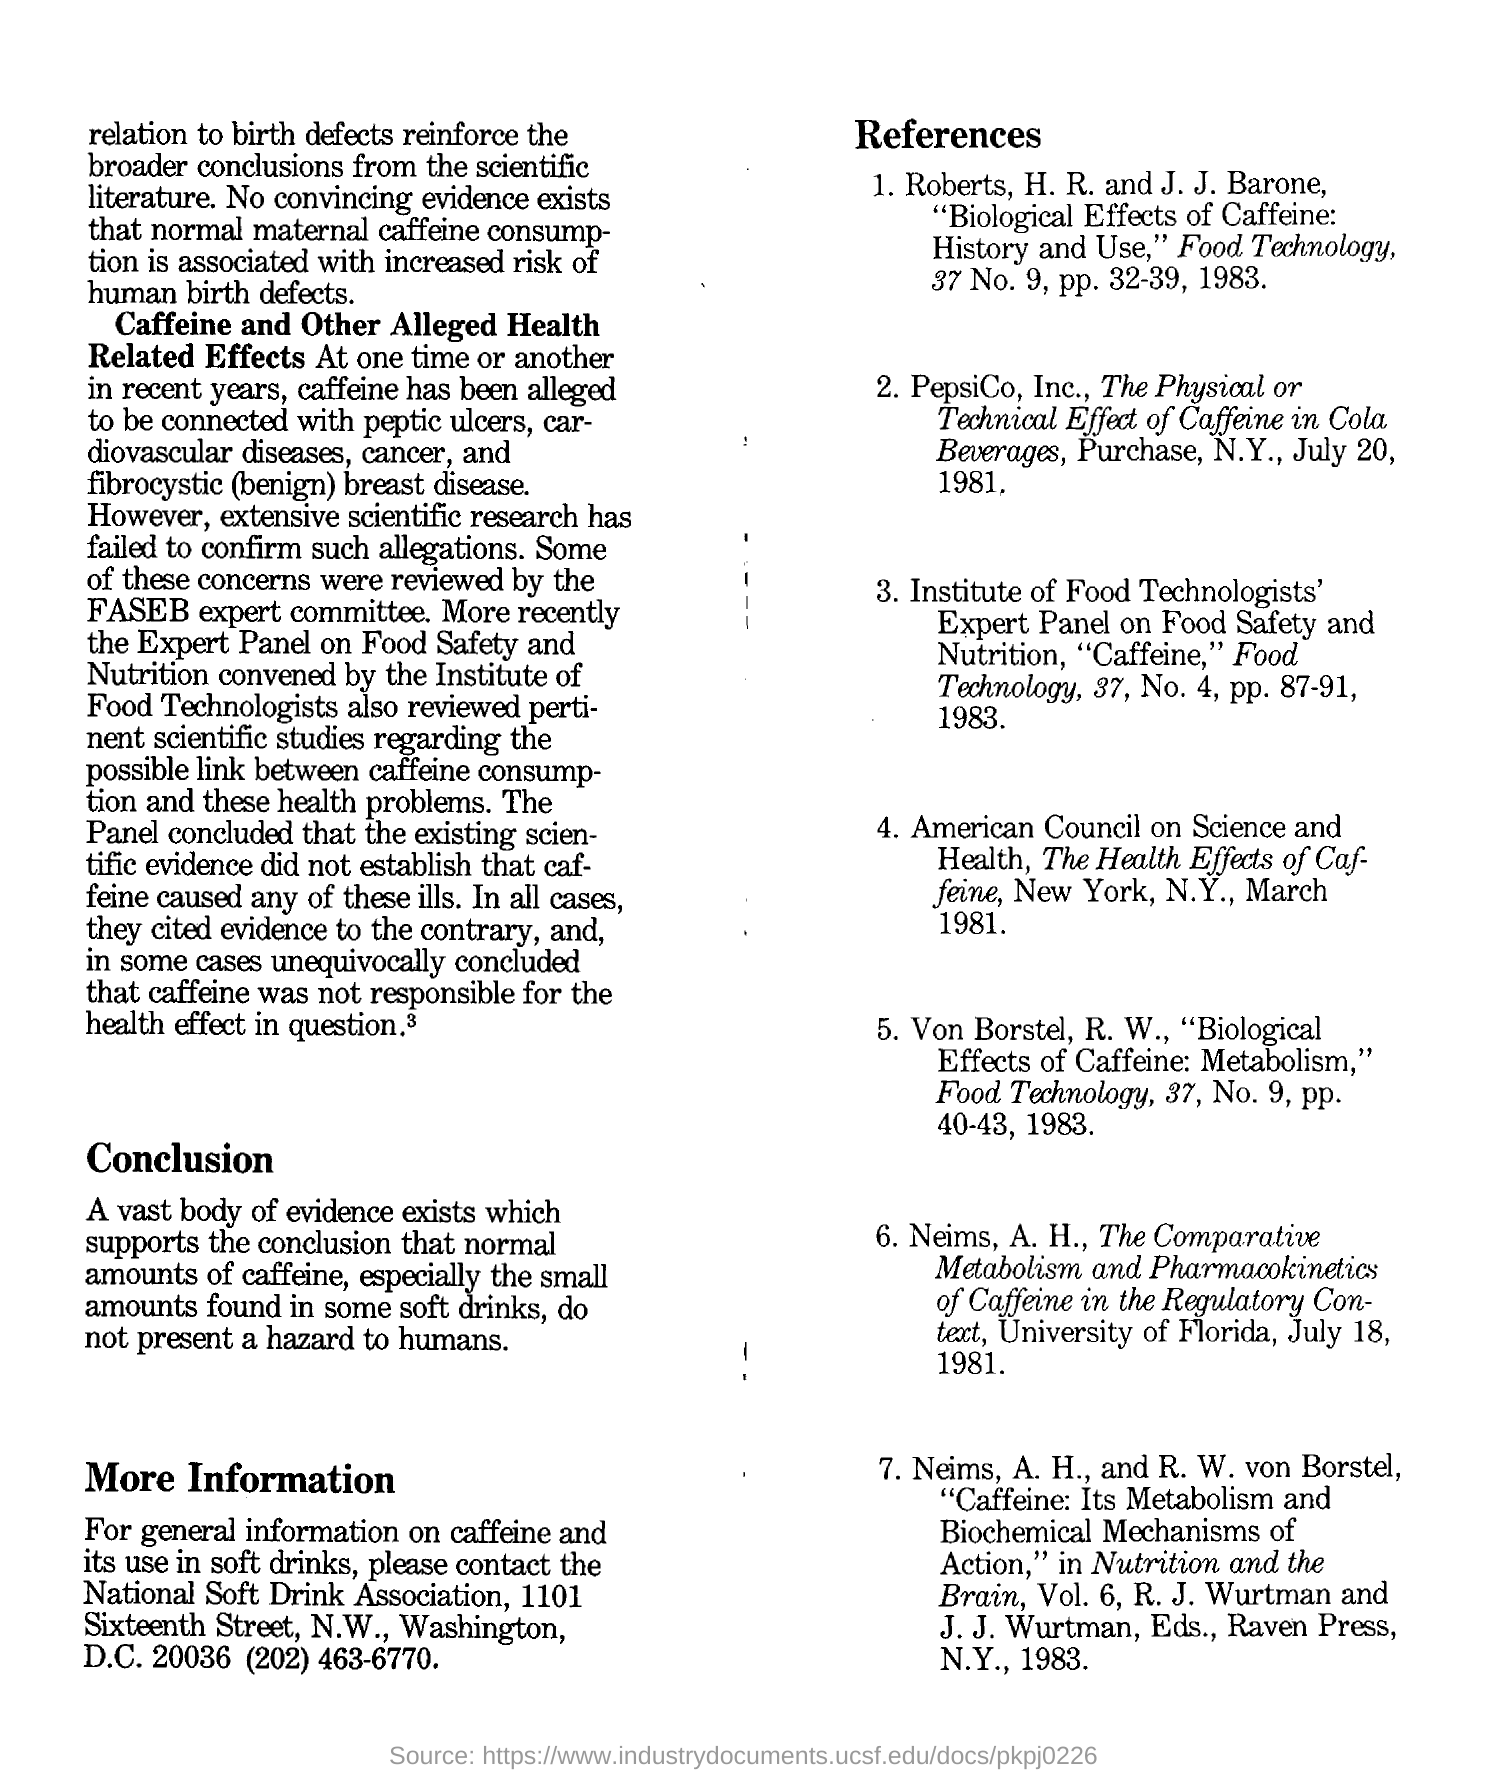Draw attention to some important aspects in this diagram. The sixth reference mentions the University of Florida. The second reference mentioned is "PepsiCo, Inc., The Physical or Technical Effect of Caffeine in Cola Beverages, Purchase, N.Y., July 20, 1981.. The first reference mentions 1983, as stated in the declaration "Which year is mentioned in the first reference? 1983.. The words written in bold in the second paragraph are "Caffeine and Other Alleged Health Related Effects. 